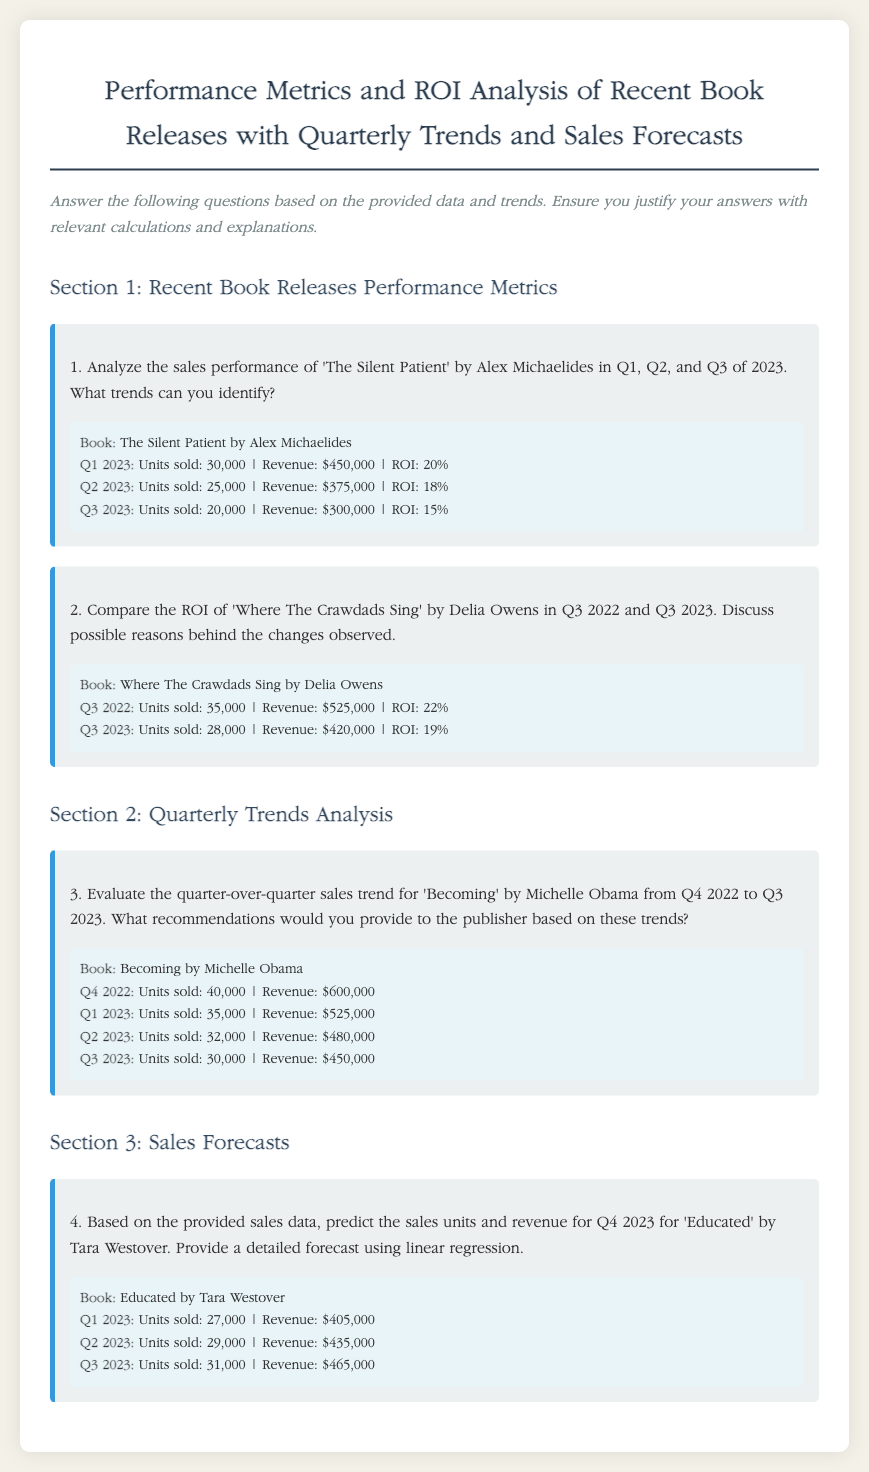What is the ROI for 'The Silent Patient' in Q1 2023? The ROI for 'The Silent Patient' in Q1 2023 is stated as 20%.
Answer: 20% How many units of 'Where The Crawdads Sing' were sold in Q3 2022? The document specifies that 35,000 units of 'Where The Crawdads Sing' were sold in Q3 2022.
Answer: 35,000 What was the revenue from 'Becoming' in Q1 2023? The revenue from 'Becoming' in Q1 2023 is $525,000, as mentioned in the document.
Answer: $525,000 What is the sales forecast for 'Educated' in Q4 2023? The document does not provide a specific forecast but implies a prediction based on previous trends.
Answer: (Not specified) Which quarter showed the highest sales for 'The Silent Patient'? Based on the provided data, Q1 2023 had the highest sales, with 30,000 units sold.
Answer: Q1 2023 What was the trend for 'Becoming' from Q4 2022 to Q3 2023? The trend shows a decline in units sold over the quarters, indicating a downward sales trend.
Answer: Decline What percentage ROI did 'Where The Crawdads Sing' have in Q3 2023? The percentage ROI for 'Where The Crawdads Sing' in Q3 2023 is stated as 19%.
Answer: 19% How much revenue was generated from 'Educated' in Q2 2023? The document states that 'Educated' generated $435,000 in revenue for Q2 2023.
Answer: $435,000 